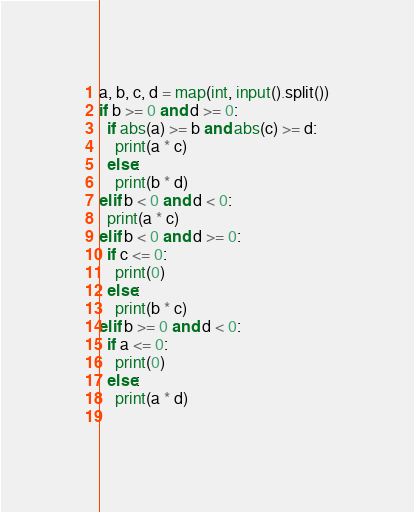Convert code to text. <code><loc_0><loc_0><loc_500><loc_500><_Python_>a, b, c, d = map(int, input().split())
if b >= 0 and d >= 0:
  if abs(a) >= b and abs(c) >= d:
    print(a * c)
  else:
    print(b * d)
elif b < 0 and d < 0:
  print(a * c)
elif b < 0 and d >= 0:
  if c <= 0:
    print(0)
  else:
    print(b * c)
elif b >= 0 and d < 0:
  if a <= 0:
    print(0)
  else:
    print(a * d)
  
</code> 